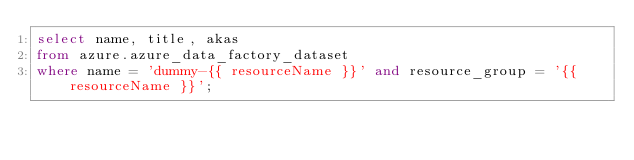Convert code to text. <code><loc_0><loc_0><loc_500><loc_500><_SQL_>select name, title, akas
from azure.azure_data_factory_dataset
where name = 'dummy-{{ resourceName }}' and resource_group = '{{ resourceName }}';</code> 